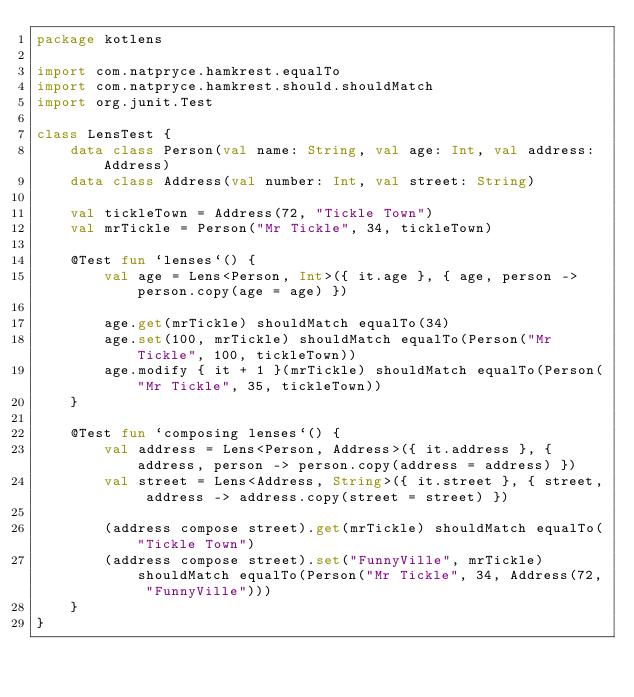<code> <loc_0><loc_0><loc_500><loc_500><_Kotlin_>package kotlens

import com.natpryce.hamkrest.equalTo
import com.natpryce.hamkrest.should.shouldMatch
import org.junit.Test

class LensTest {
    data class Person(val name: String, val age: Int, val address: Address)
    data class Address(val number: Int, val street: String)

    val tickleTown = Address(72, "Tickle Town")
    val mrTickle = Person("Mr Tickle", 34, tickleTown)

    @Test fun `lenses`() {
        val age = Lens<Person, Int>({ it.age }, { age, person -> person.copy(age = age) })

        age.get(mrTickle) shouldMatch equalTo(34)
        age.set(100, mrTickle) shouldMatch equalTo(Person("Mr Tickle", 100, tickleTown))
        age.modify { it + 1 }(mrTickle) shouldMatch equalTo(Person("Mr Tickle", 35, tickleTown))
    }

    @Test fun `composing lenses`() {
        val address = Lens<Person, Address>({ it.address }, { address, person -> person.copy(address = address) })
        val street = Lens<Address, String>({ it.street }, { street, address -> address.copy(street = street) })

        (address compose street).get(mrTickle) shouldMatch equalTo("Tickle Town")
        (address compose street).set("FunnyVille", mrTickle) shouldMatch equalTo(Person("Mr Tickle", 34, Address(72, "FunnyVille")))
    }
}</code> 